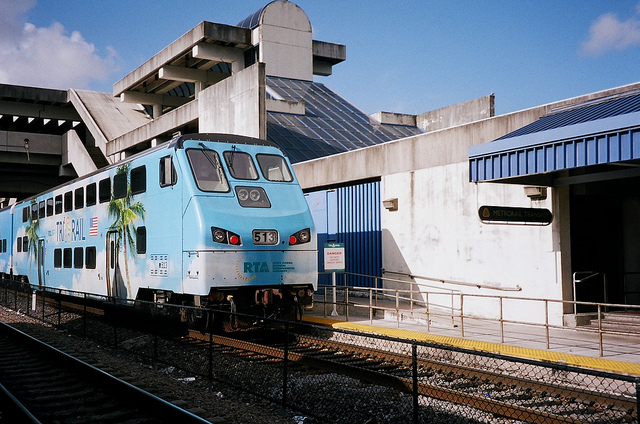Extract all visible text content from this image. 513 RTA RAIL 